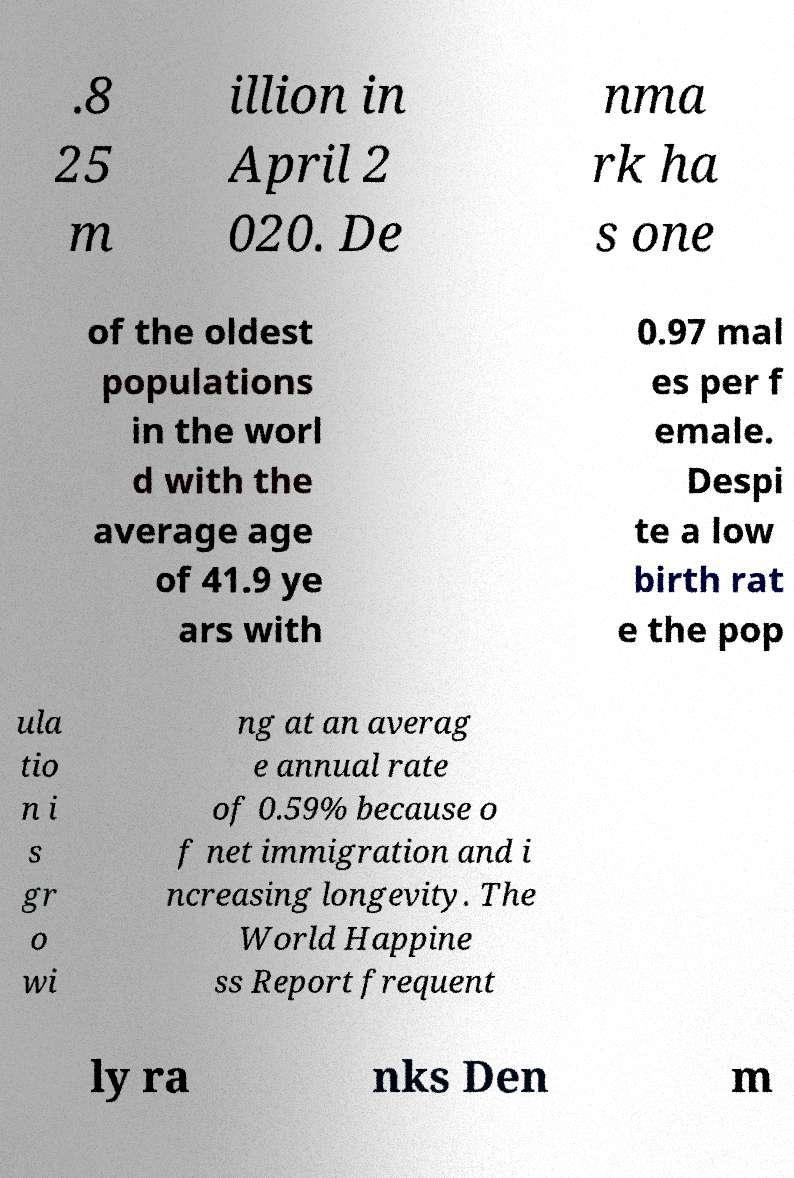Could you assist in decoding the text presented in this image and type it out clearly? .8 25 m illion in April 2 020. De nma rk ha s one of the oldest populations in the worl d with the average age of 41.9 ye ars with 0.97 mal es per f emale. Despi te a low birth rat e the pop ula tio n i s gr o wi ng at an averag e annual rate of 0.59% because o f net immigration and i ncreasing longevity. The World Happine ss Report frequent ly ra nks Den m 